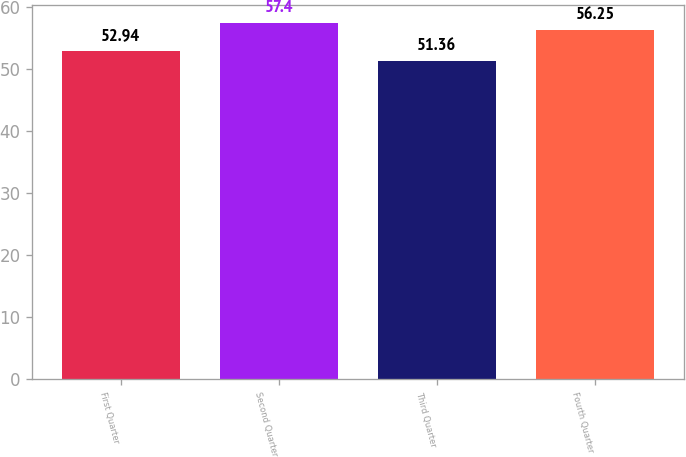Convert chart. <chart><loc_0><loc_0><loc_500><loc_500><bar_chart><fcel>First Quarter<fcel>Second Quarter<fcel>Third Quarter<fcel>Fourth Quarter<nl><fcel>52.94<fcel>57.4<fcel>51.36<fcel>56.25<nl></chart> 